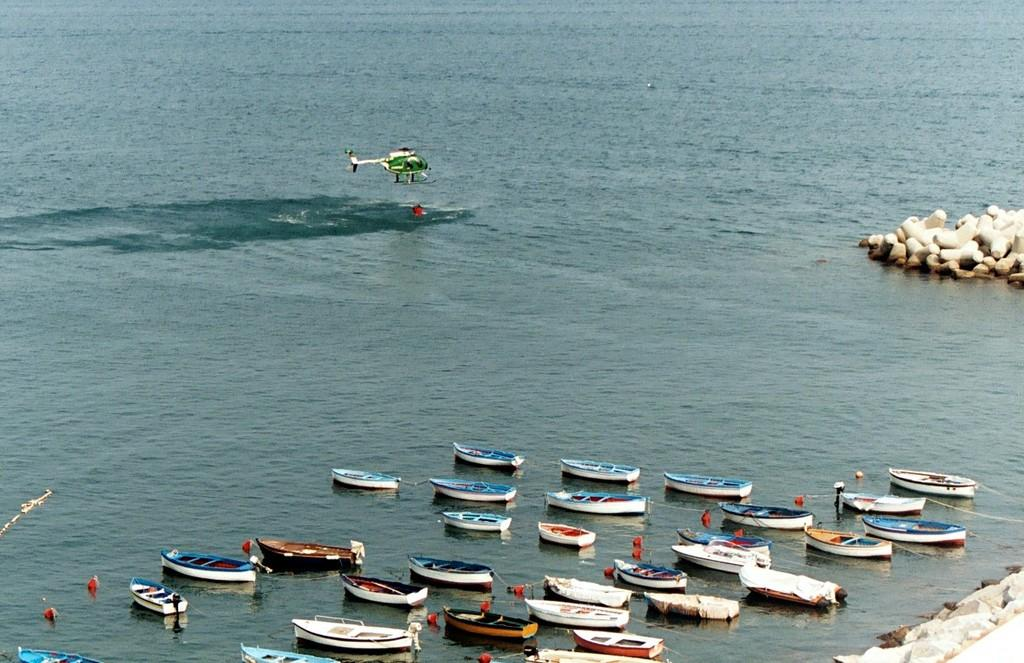What is the main subject in the center of the image? There is a helicopter in the center of the image. What can be seen at the bottom of the image? There are boats and water visible at the bottom of the image. What type of terrain is on the right side of the image? There are stones on the right side of the image. What type of destruction can be seen caused by the helicopter in the image? There is no destruction caused by the helicopter in the image; it is simply present in the center of the image. Can you see any crushed glass in the image? There is no crushed glass present in the image. 